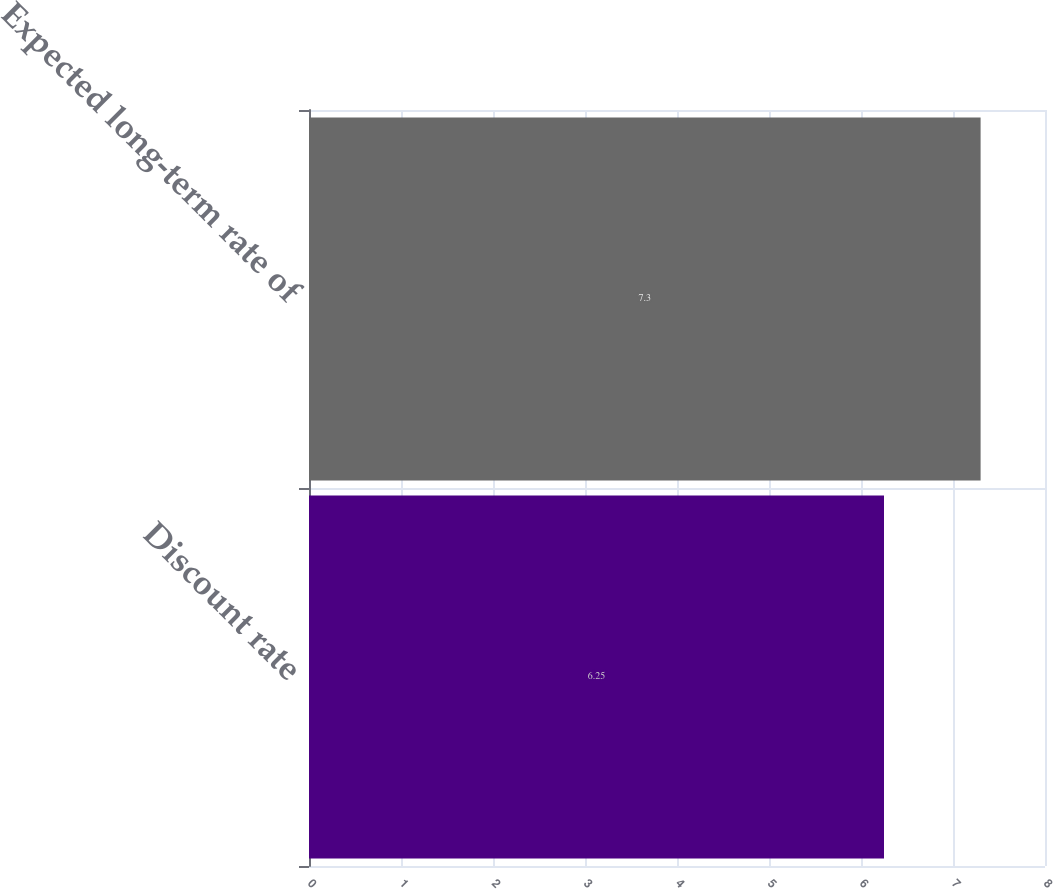Convert chart. <chart><loc_0><loc_0><loc_500><loc_500><bar_chart><fcel>Discount rate<fcel>Expected long-term rate of<nl><fcel>6.25<fcel>7.3<nl></chart> 